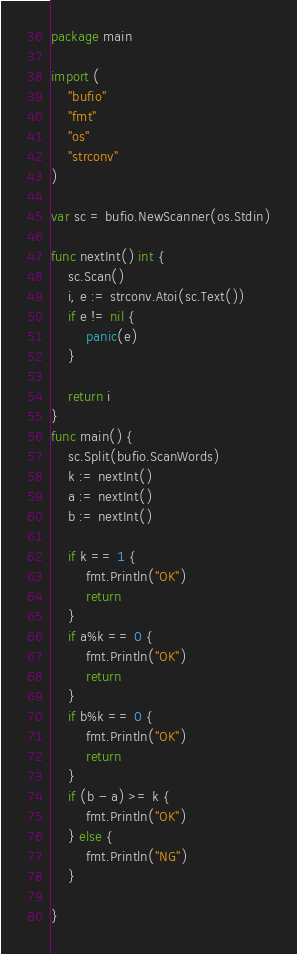<code> <loc_0><loc_0><loc_500><loc_500><_Go_>package main

import (
	"bufio"
	"fmt"
	"os"
	"strconv"
)

var sc = bufio.NewScanner(os.Stdin)

func nextInt() int {
	sc.Scan()
	i, e := strconv.Atoi(sc.Text())
	if e != nil {
		panic(e)
	}

	return i
}
func main() {
	sc.Split(bufio.ScanWords)
	k := nextInt()
	a := nextInt()
	b := nextInt()

	if k == 1 {
		fmt.Println("OK")
		return
	}
	if a%k == 0 {
		fmt.Println("OK")
		return
	}
	if b%k == 0 {
		fmt.Println("OK")
		return
	}
	if (b - a) >= k {
		fmt.Println("OK")
	} else {
		fmt.Println("NG")
	}

}
</code> 